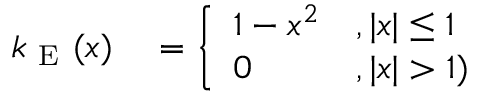Convert formula to latex. <formula><loc_0><loc_0><loc_500><loc_500>\begin{array} { r l } { k _ { E } ( x ) } & = \left \{ \begin{array} { l l } { 1 - x ^ { 2 } } & { , | x | \leq 1 } \\ { 0 } & { , | x | > 1 ) } \end{array} } \end{array}</formula> 